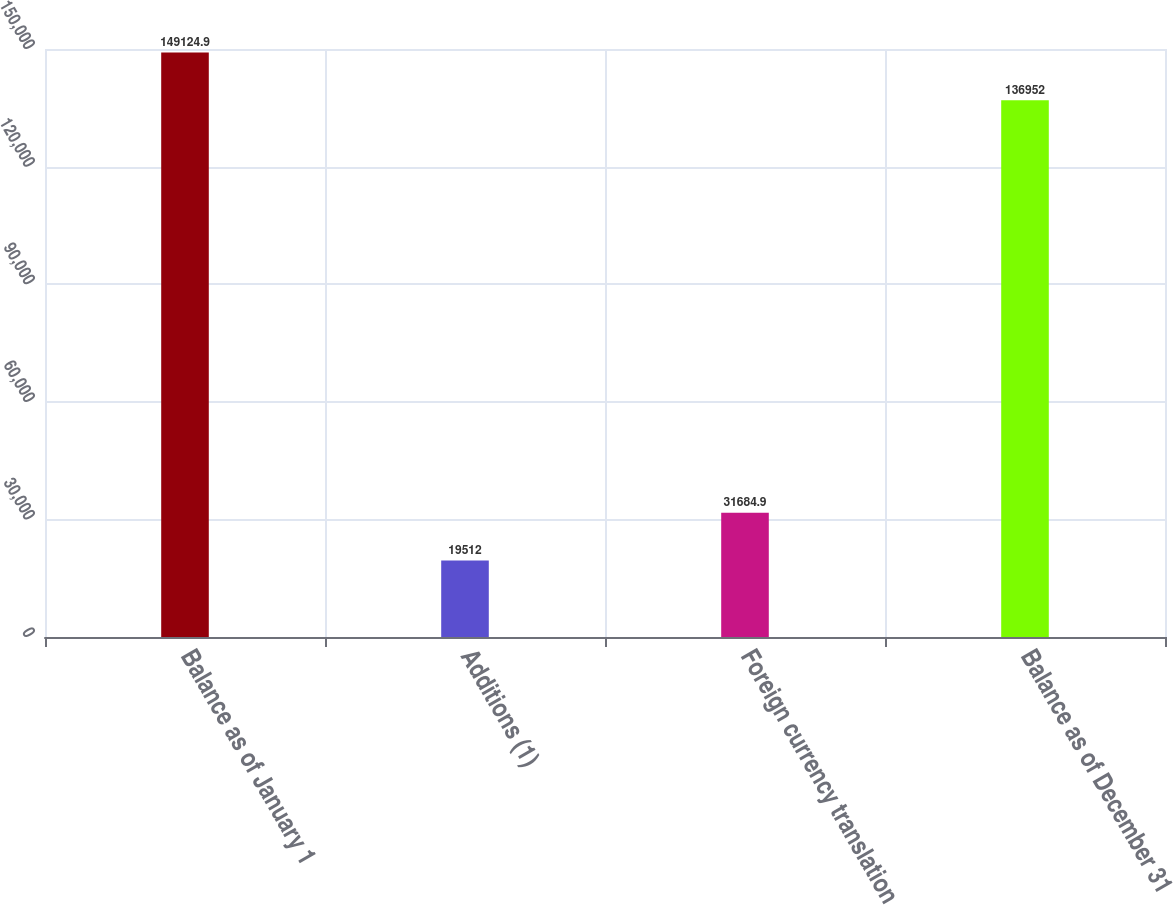Convert chart. <chart><loc_0><loc_0><loc_500><loc_500><bar_chart><fcel>Balance as of January 1<fcel>Additions (1)<fcel>Foreign currency translation<fcel>Balance as of December 31<nl><fcel>149125<fcel>19512<fcel>31684.9<fcel>136952<nl></chart> 